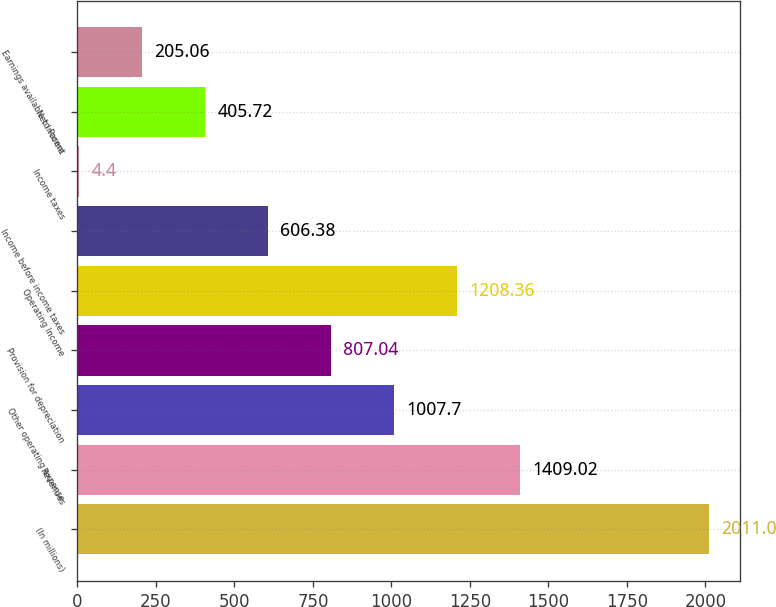Convert chart to OTSL. <chart><loc_0><loc_0><loc_500><loc_500><bar_chart><fcel>(In millions)<fcel>Revenues<fcel>Other operating expense<fcel>Provision for depreciation<fcel>Operating Income<fcel>Income before income taxes<fcel>Income taxes<fcel>Net Income<fcel>Earnings available to Parent<nl><fcel>2011<fcel>1409.02<fcel>1007.7<fcel>807.04<fcel>1208.36<fcel>606.38<fcel>4.4<fcel>405.72<fcel>205.06<nl></chart> 